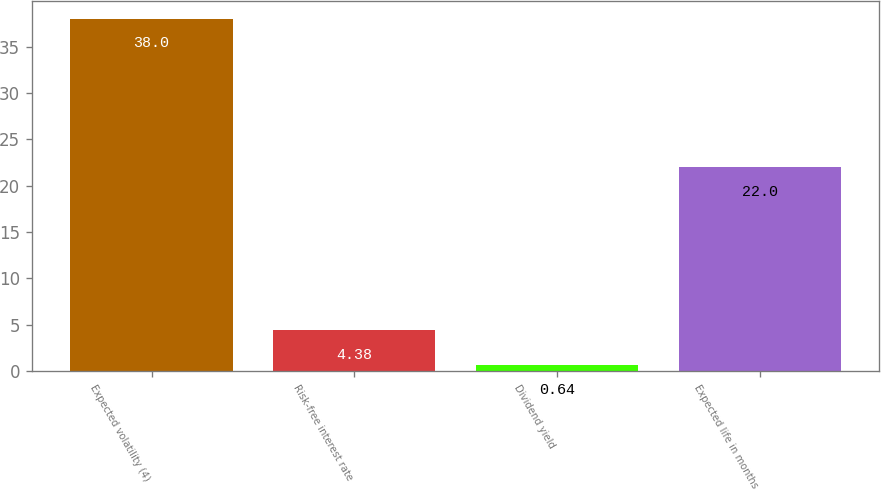Convert chart to OTSL. <chart><loc_0><loc_0><loc_500><loc_500><bar_chart><fcel>Expected volatility (4)<fcel>Risk-free interest rate<fcel>Dividend yield<fcel>Expected life in months<nl><fcel>38<fcel>4.38<fcel>0.64<fcel>22<nl></chart> 